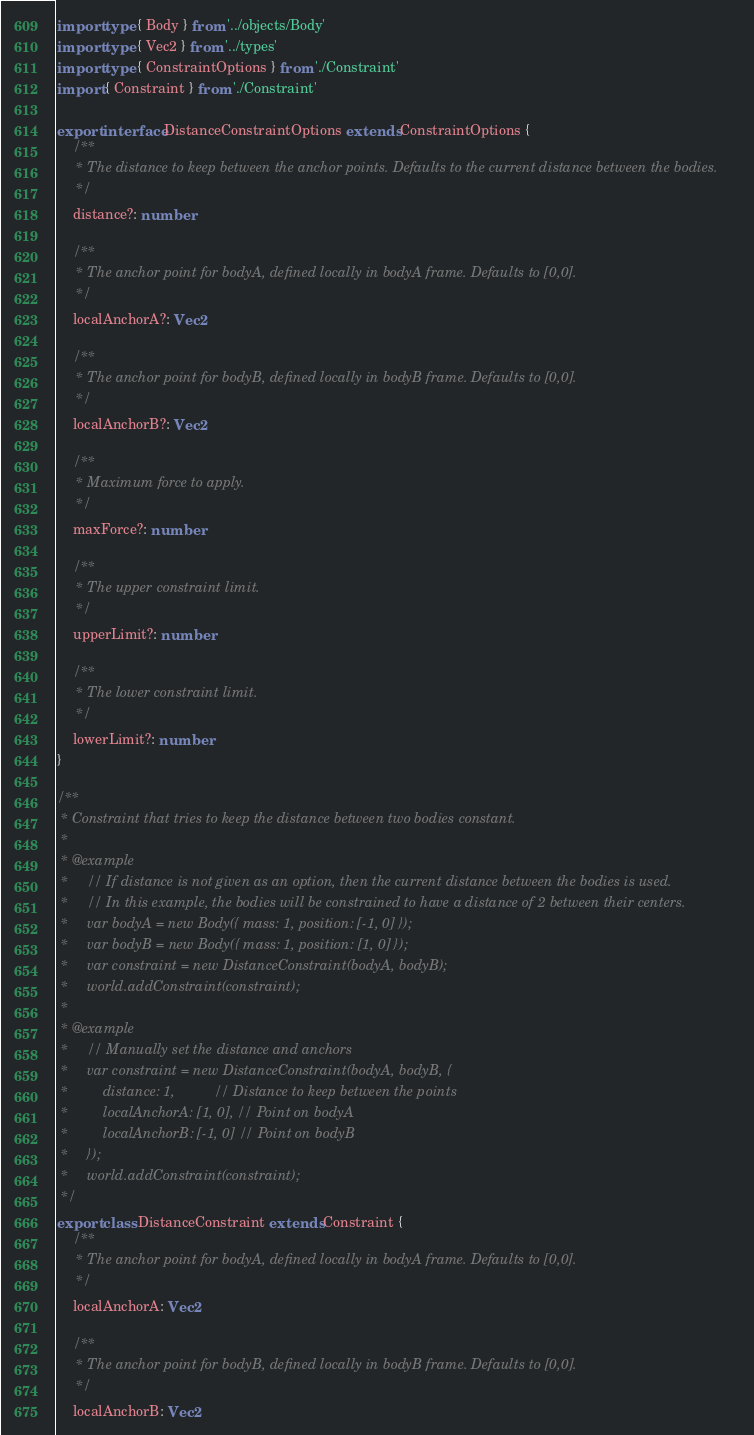Convert code to text. <code><loc_0><loc_0><loc_500><loc_500><_TypeScript_>import type { Body } from '../objects/Body'
import type { Vec2 } from '../types'
import type { ConstraintOptions } from './Constraint'
import { Constraint } from './Constraint'

export interface DistanceConstraintOptions extends ConstraintOptions {
    /**
     * The distance to keep between the anchor points. Defaults to the current distance between the bodies.
     */
    distance?: number

    /**
     * The anchor point for bodyA, defined locally in bodyA frame. Defaults to [0,0].
     */
    localAnchorA?: Vec2

    /**
     * The anchor point for bodyB, defined locally in bodyB frame. Defaults to [0,0].
     */
    localAnchorB?: Vec2

    /**
     * Maximum force to apply.
     */
    maxForce?: number

    /**
     * The upper constraint limit.
     */
    upperLimit?: number

    /**
     * The lower constraint limit.
     */
    lowerLimit?: number
}

/**
 * Constraint that tries to keep the distance between two bodies constant.
 *
 * @example
 *     // If distance is not given as an option, then the current distance between the bodies is used.
 *     // In this example, the bodies will be constrained to have a distance of 2 between their centers.
 *     var bodyA = new Body({ mass: 1, position: [-1, 0] });
 *     var bodyB = new Body({ mass: 1, position: [1, 0] });
 *     var constraint = new DistanceConstraint(bodyA, bodyB);
 *     world.addConstraint(constraint);
 *
 * @example
 *     // Manually set the distance and anchors
 *     var constraint = new DistanceConstraint(bodyA, bodyB, {
 *         distance: 1,          // Distance to keep between the points
 *         localAnchorA: [1, 0], // Point on bodyA
 *         localAnchorB: [-1, 0] // Point on bodyB
 *     });
 *     world.addConstraint(constraint);
 */
export class DistanceConstraint extends Constraint {
    /**
     * The anchor point for bodyA, defined locally in bodyA frame. Defaults to [0,0].
     */
    localAnchorA: Vec2

    /**
     * The anchor point for bodyB, defined locally in bodyB frame. Defaults to [0,0].
     */
    localAnchorB: Vec2
</code> 